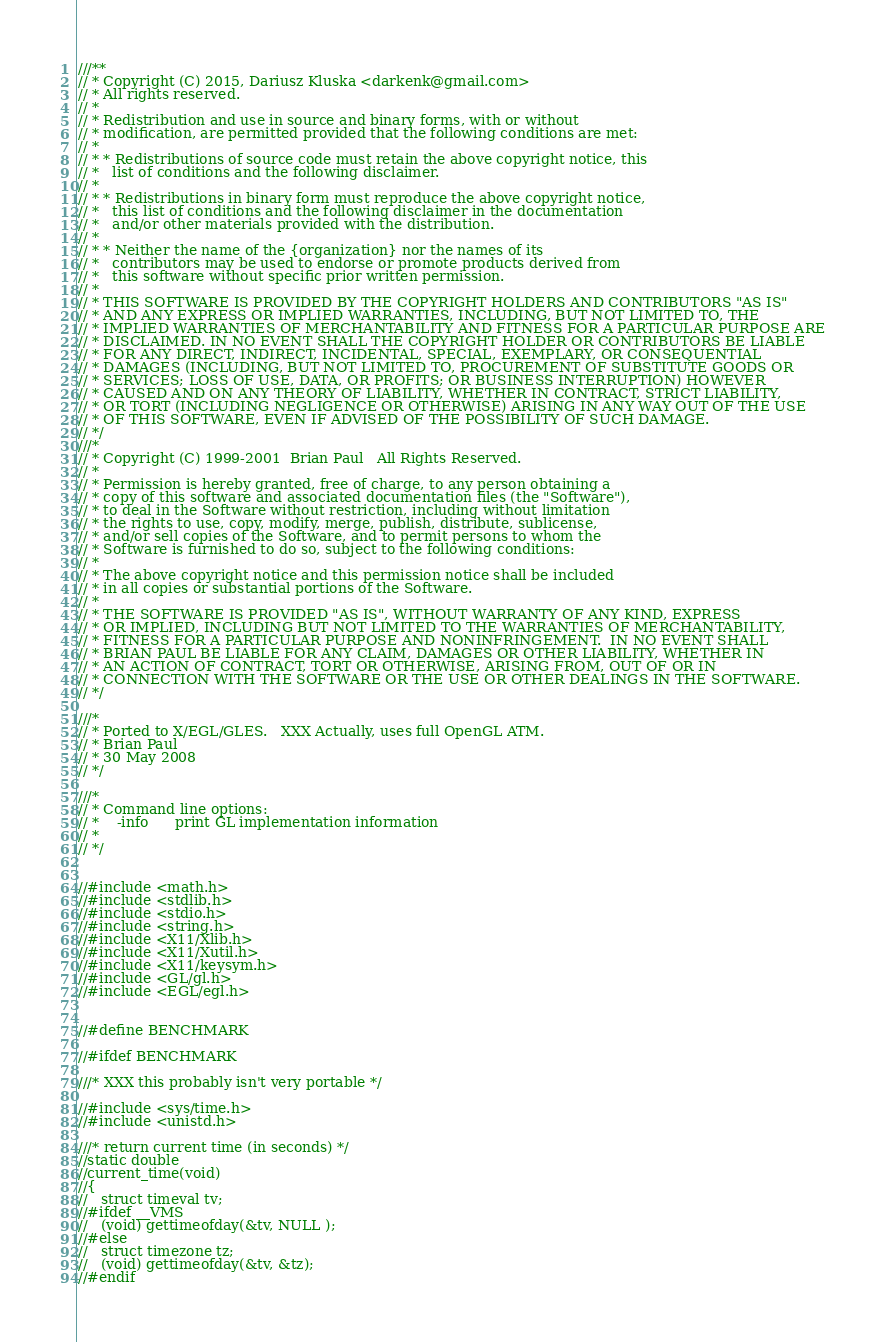<code> <loc_0><loc_0><loc_500><loc_500><_C++_>///**
// * Copyright (C) 2015, Dariusz Kluska <darkenk@gmail.com>
// * All rights reserved.
// *
// * Redistribution and use in source and binary forms, with or without
// * modification, are permitted provided that the following conditions are met:
// *
// * * Redistributions of source code must retain the above copyright notice, this
// *   list of conditions and the following disclaimer.
// *
// * * Redistributions in binary form must reproduce the above copyright notice,
// *   this list of conditions and the following disclaimer in the documentation
// *   and/or other materials provided with the distribution.
// *
// * * Neither the name of the {organization} nor the names of its
// *   contributors may be used to endorse or promote products derived from
// *   this software without specific prior written permission.
// *
// * THIS SOFTWARE IS PROVIDED BY THE COPYRIGHT HOLDERS AND CONTRIBUTORS "AS IS"
// * AND ANY EXPRESS OR IMPLIED WARRANTIES, INCLUDING, BUT NOT LIMITED TO, THE
// * IMPLIED WARRANTIES OF MERCHANTABILITY AND FITNESS FOR A PARTICULAR PURPOSE ARE
// * DISCLAIMED. IN NO EVENT SHALL THE COPYRIGHT HOLDER OR CONTRIBUTORS BE LIABLE
// * FOR ANY DIRECT, INDIRECT, INCIDENTAL, SPECIAL, EXEMPLARY, OR CONSEQUENTIAL
// * DAMAGES (INCLUDING, BUT NOT LIMITED TO, PROCUREMENT OF SUBSTITUTE GOODS OR
// * SERVICES; LOSS OF USE, DATA, OR PROFITS; OR BUSINESS INTERRUPTION) HOWEVER
// * CAUSED AND ON ANY THEORY OF LIABILITY, WHETHER IN CONTRACT, STRICT LIABILITY,
// * OR TORT (INCLUDING NEGLIGENCE OR OTHERWISE) ARISING IN ANY WAY OUT OF THE USE
// * OF THIS SOFTWARE, EVEN IF ADVISED OF THE POSSIBILITY OF SUCH DAMAGE.
// */
///*
// * Copyright (C) 1999-2001  Brian Paul   All Rights Reserved.
// *
// * Permission is hereby granted, free of charge, to any person obtaining a
// * copy of this software and associated documentation files (the "Software"),
// * to deal in the Software without restriction, including without limitation
// * the rights to use, copy, modify, merge, publish, distribute, sublicense,
// * and/or sell copies of the Software, and to permit persons to whom the
// * Software is furnished to do so, subject to the following conditions:
// *
// * The above copyright notice and this permission notice shall be included
// * in all copies or substantial portions of the Software.
// *
// * THE SOFTWARE IS PROVIDED "AS IS", WITHOUT WARRANTY OF ANY KIND, EXPRESS
// * OR IMPLIED, INCLUDING BUT NOT LIMITED TO THE WARRANTIES OF MERCHANTABILITY,
// * FITNESS FOR A PARTICULAR PURPOSE AND NONINFRINGEMENT.  IN NO EVENT SHALL
// * BRIAN PAUL BE LIABLE FOR ANY CLAIM, DAMAGES OR OTHER LIABILITY, WHETHER IN
// * AN ACTION OF CONTRACT, TORT OR OTHERWISE, ARISING FROM, OUT OF OR IN
// * CONNECTION WITH THE SOFTWARE OR THE USE OR OTHER DEALINGS IN THE SOFTWARE.
// */

///*
// * Ported to X/EGL/GLES.   XXX Actually, uses full OpenGL ATM.
// * Brian Paul
// * 30 May 2008
// */

///*
// * Command line options:
// *    -info      print GL implementation information
// *
// */


//#include <math.h>
//#include <stdlib.h>
//#include <stdio.h>
//#include <string.h>
//#include <X11/Xlib.h>
//#include <X11/Xutil.h>
//#include <X11/keysym.h>
//#include <GL/gl.h>
//#include <EGL/egl.h>


//#define BENCHMARK

//#ifdef BENCHMARK

///* XXX this probably isn't very portable */

//#include <sys/time.h>
//#include <unistd.h>

///* return current time (in seconds) */
//static double
//current_time(void)
//{
//   struct timeval tv;
//#ifdef __VMS
//   (void) gettimeofday(&tv, NULL );
//#else
//   struct timezone tz;
//   (void) gettimeofday(&tv, &tz);
//#endif</code> 